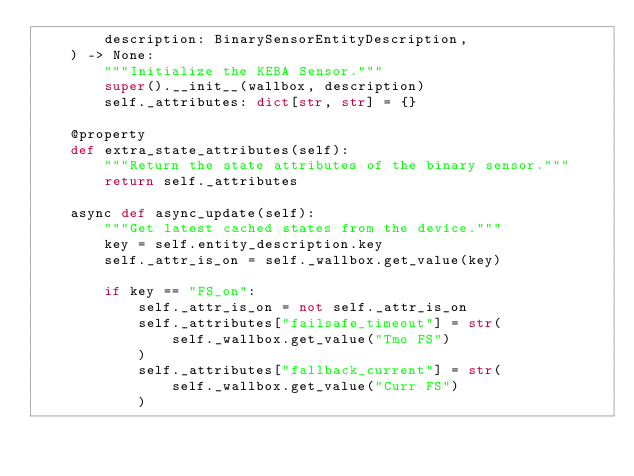<code> <loc_0><loc_0><loc_500><loc_500><_Python_>        description: BinarySensorEntityDescription,
    ) -> None:
        """Initialize the KEBA Sensor."""
        super().__init__(wallbox, description)
        self._attributes: dict[str, str] = {}

    @property
    def extra_state_attributes(self):
        """Return the state attributes of the binary sensor."""
        return self._attributes

    async def async_update(self):
        """Get latest cached states from the device."""
        key = self.entity_description.key
        self._attr_is_on = self._wallbox.get_value(key)

        if key == "FS_on":
            self._attr_is_on = not self._attr_is_on
            self._attributes["failsafe_timeout"] = str(
                self._wallbox.get_value("Tmo FS")
            )
            self._attributes["fallback_current"] = str(
                self._wallbox.get_value("Curr FS")
            )
</code> 